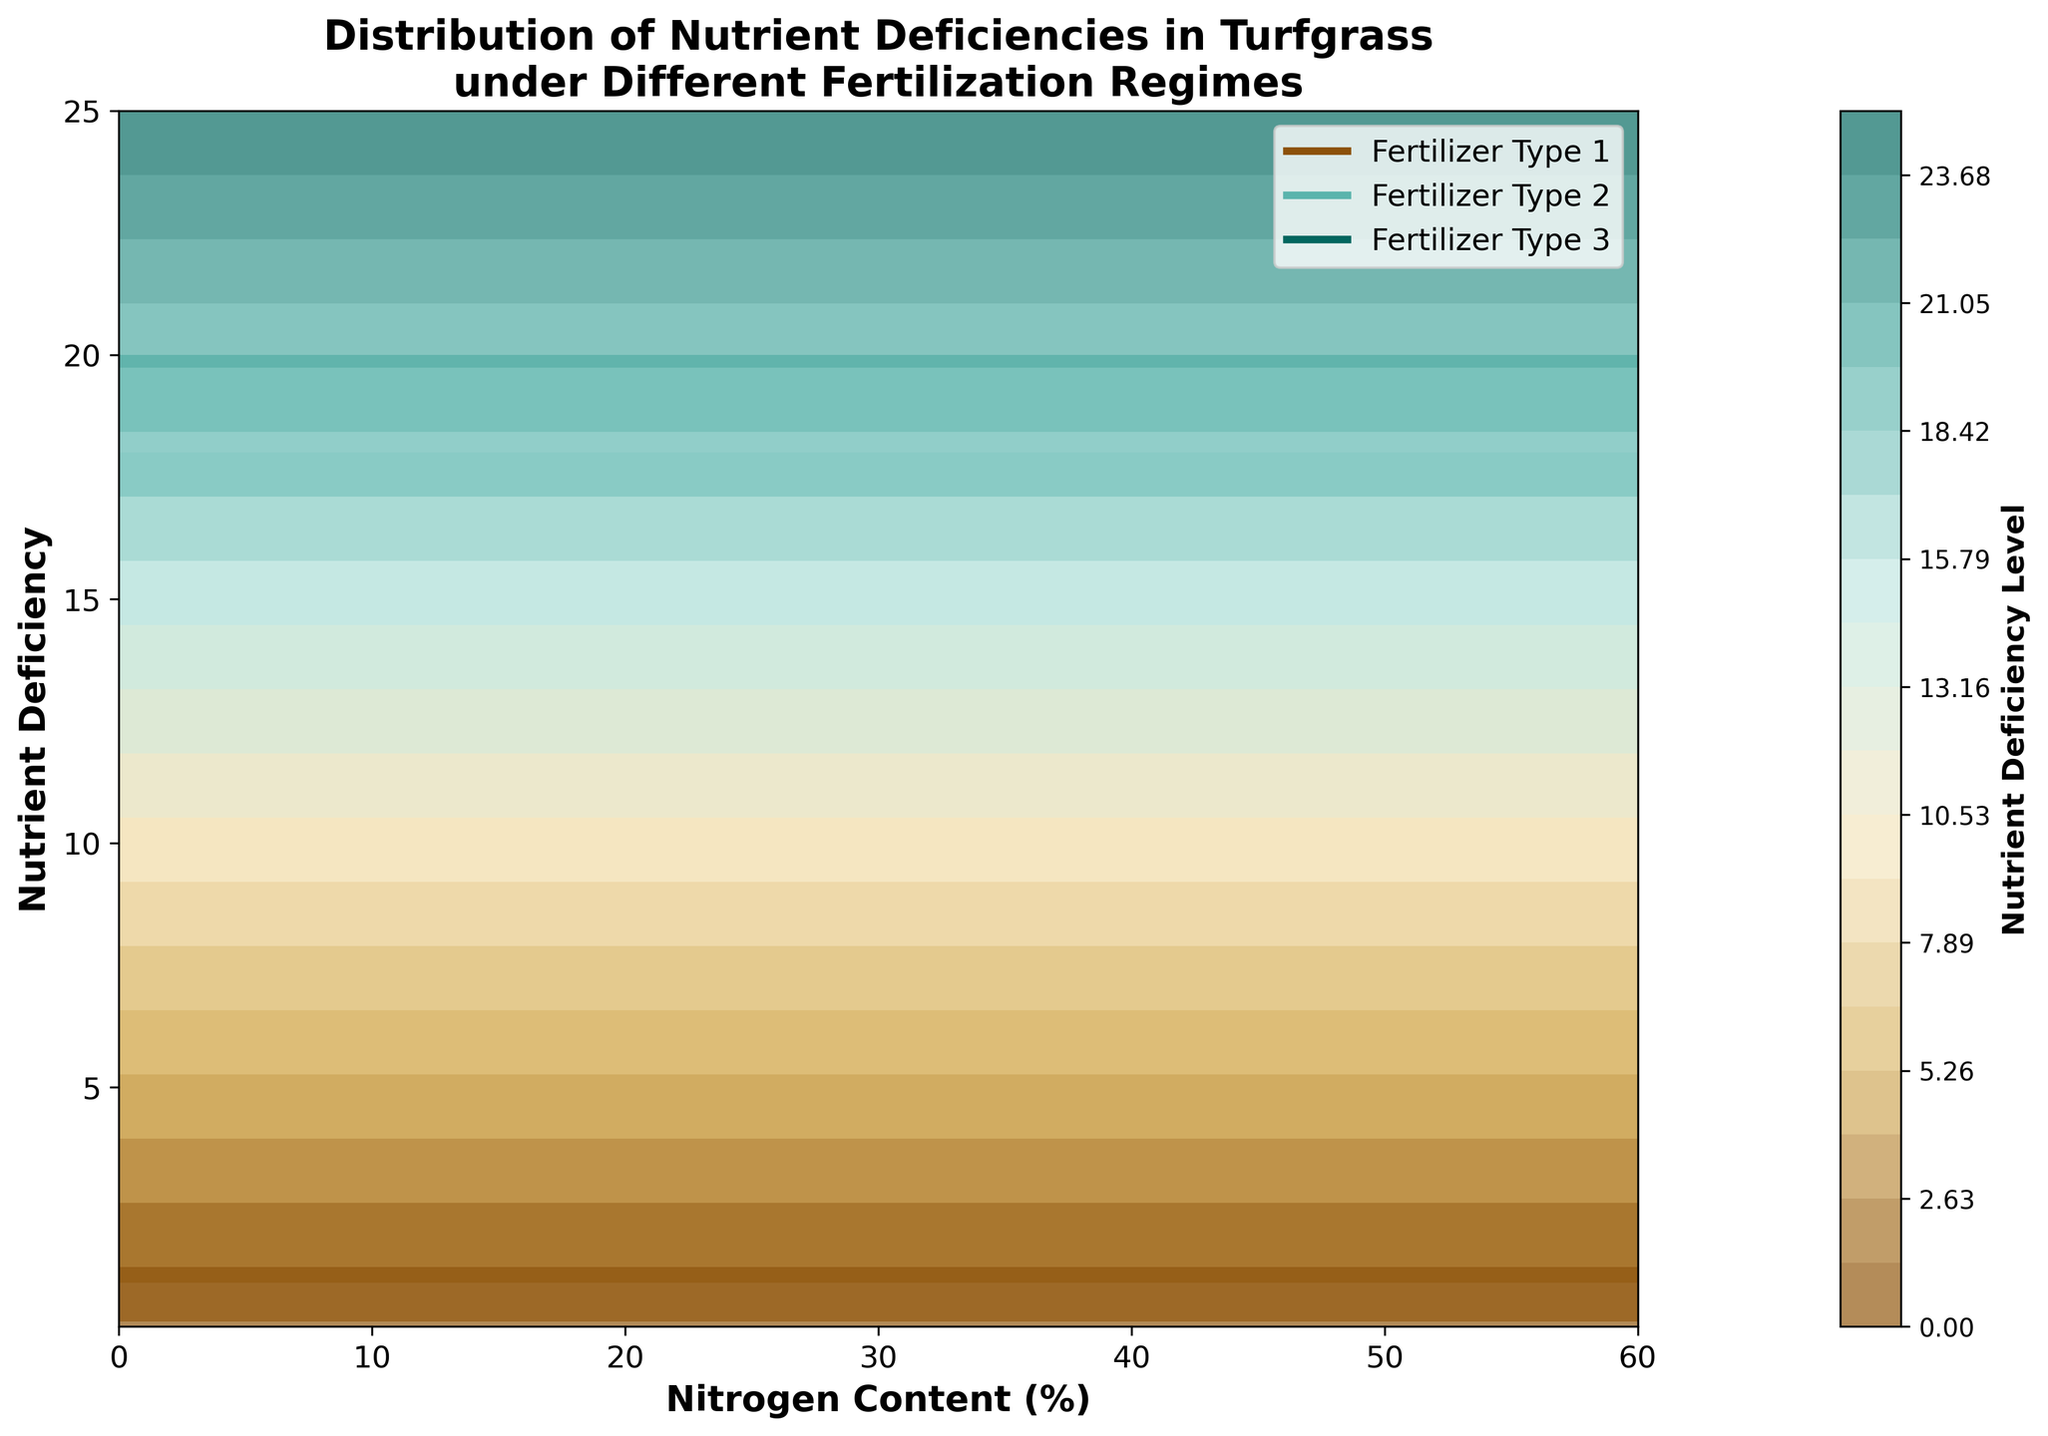What is the title of the figure? The title is usually located at the top of the figure and provides a summary of the depicted data. Here, it is clearly labeled.
Answer: Distribution of Nutrient Deficiencies in Turfgrass under Different Fertilization Regimes What are the labels on the x and y axes? The x and y axis labels specify what each axis represents. These labels help understand what the data points refer to.
Answer: The x-axis is labeled as "Nitrogen Content (%)" and the y-axis is labeled as "Nutrient Deficiency." Which color represents "Fertilizer Type 1" in the plot? The legend located within the plot indicates the color associated with each fertilizer type. The plot's legend includes lines of different colors.
Answer: The color representing "Fertilizer Type 1" is dark brown (#8c510a in the internal code) How does the nutrient deficiency level change as nitrogen content increases for "Fertilizer Type 3"? Look at the corresponding contours for "Fertilizer Type 3" at varying levels of nitrogen content. As nitrogen increases, note how the contours and their associated levels change.
Answer: Nutrient deficiency decreases as nitrogen content increases At which nitrogen content does "Fertilizer Type 2" start showing a nutrient deficiency level below 1? Observe the contour lines corresponding to "Fertilizer Type 2". Identify where the values drop below 1.
Answer: Around 40% nitrogen content What is the highest nutrient deficiency level shown in the plot? Examine all contour labels, including their color gradients, to identify the maximum value shown across all data series.
Answer: The highest nutrient deficiency level is 25 Which fertilizer type shows the steepest decline in nutrient deficiency as nitrogen content increases? Compare the gradient slopes of contours for all three fertilizer types to see which one decreases the fastest as nitrogen content rises.
Answer: "Fertilizer Type 1" How do the nutrient deficiency levels for "Fertilizer Type 1" compare to "Fertilizer Type 2" around 20% nitrogen content? Look at the contour levels for both types at around 20% nitrogen to compare their values.
Answer: "Fertilizer Type 1" has higher deficiency levels compared to "Fertilizer Type 2" At 30% nitrogen content, which fertilizer type has the lowest nutrient deficiency? Examine the nutrient deficiency levels of the contour lines for all fertilizer types at 30% nitrogen content.
Answer: "Fertilizer Type 3" 